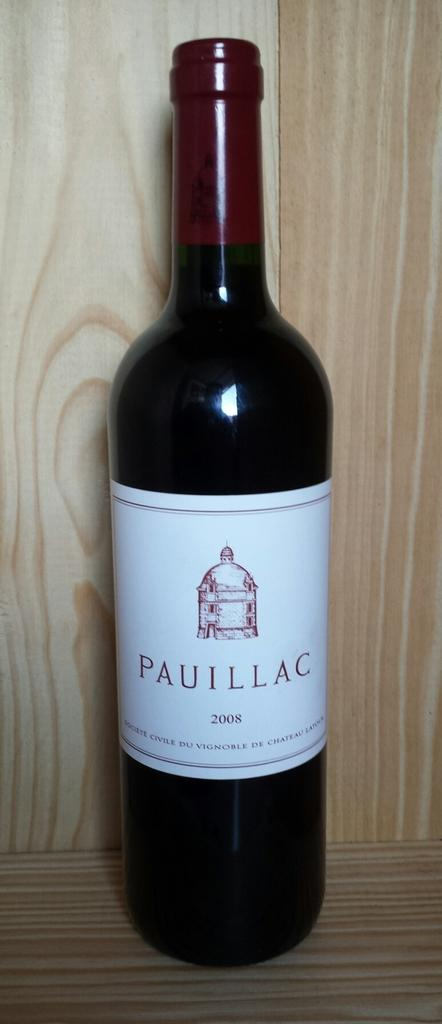<image>
Present a compact description of the photo's key features. the word pauillac is on a wine bottle 